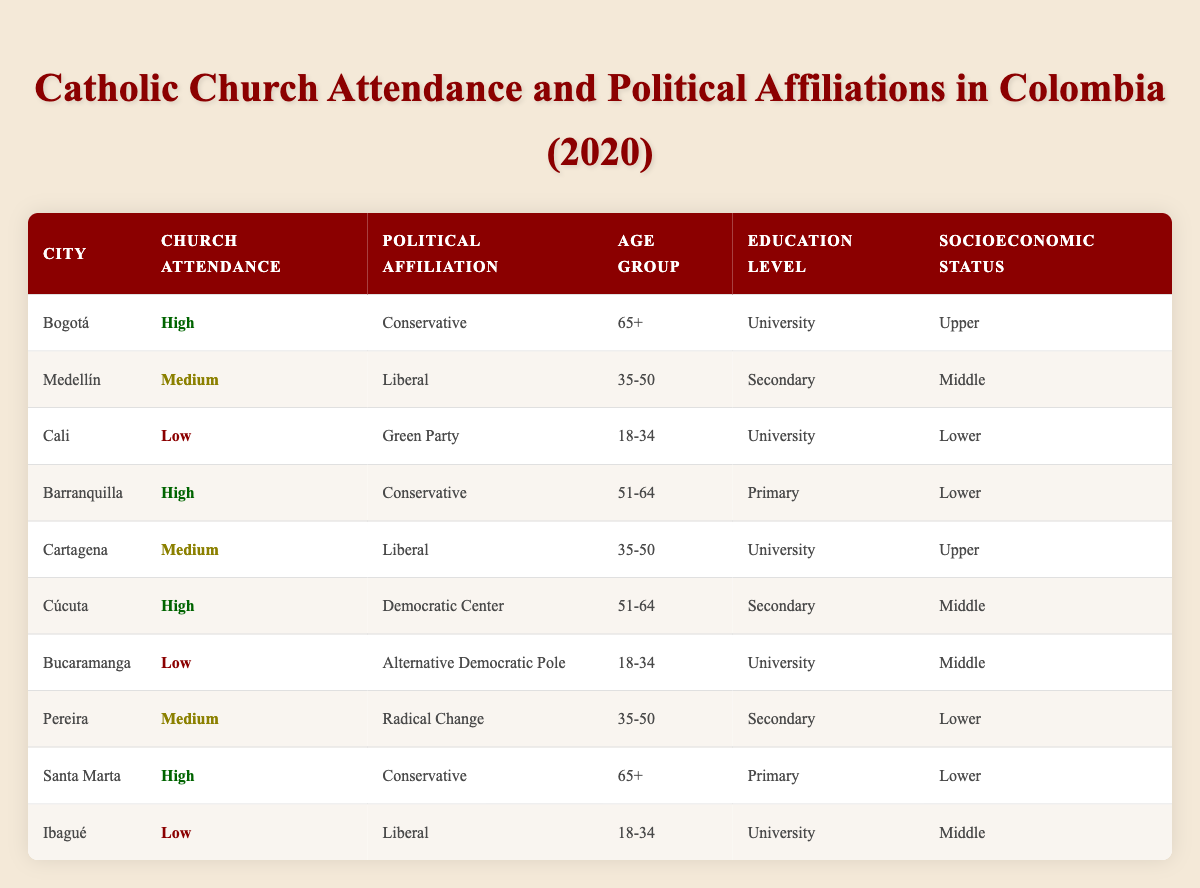What is the political affiliation of the residents of Bogotá? The table lists Bogotá with a Church Attendance labeled 'High' and a Political Affiliation of 'Conservative'. Thus, the political affiliation of the residents of Bogotá is Conservative.
Answer: Conservative How many cities have High Church Attendance and are affiliated with the Conservative party? From the table, Bogotá, Barranquilla, and Santa Marta are the three cities listed with High Church Attendance and Conservative affiliation. Therefore, there are three cities that meet these criteria.
Answer: 3 Are there any cities where individuals with Low Church Attendance are affiliated with Liberal parties? The table shows that Cali and Ibagué have Low Church Attendance and are associated with the Liberal political affiliation. Hence, the answer is yes.
Answer: Yes What is the average age group of individuals attending Church High in the provided data? The table lists three cities with High Church Attendance: Bogotá (65+), Barranquilla (51-64), and Santa Marta (65+). To find the average, add the age groups (65+ + 51-64 + 65+) and divide by 3. The calculation leads us to average age group (average of the middle age of the groups) results in roughly 63+ years.
Answer: 63+ Is there a relationship between Church Attendance and Political Affiliation among younger age groups (18-34)? In the table, Cali and Bucaramanga show Low Church Attendance with affiliations to the Green Party and Alternative Democratic Pole, while Ibagué has Low Church Attendance and is affiliated with the Liberal party. All relate to individuals aged 18-34. Therefore, political diversity exists in this age group despite the Low Church Attendance. Therefore, a relationship exists emphasizing Low Church Attendance correlates with specific political affiliations among younger groups.
Answer: Yes How many political affiliations are represented in cities with Medium Church Attendance? Analyzing the table, the cities of Medellín (Liberal), Cartagena (Liberal), and Pereira (Radical Change) show Medium Church Attendance, which reflects three different political affiliations.
Answer: 3 Which education level is most prevalent among participants with High Church Attendance? The table indicates that the individuals with High Church Attendance have diverse education levels: Bogotá (University), Barranquilla (Primary), Santa Marta (Primary). While Primary education is represented twice and University education once, Primary education is the most prevalent among the High Church Attendees.
Answer: Primary What is the socioeconomic status of the city with the Lowest Church Attendance? For cities with Low Church Attendance, Cali and Bucaramanga are both marked as Lower and Middle socioeconomic statuses respectively. Therefore, the answer indicates multiple statuses, with Lower being the most frequent.
Answer: Lower What socio-economic class corresponds to individuals affiliated with the Democratic Center Party? Analyzing the data, Cúcuta, which is affiliated with the Democratic Center party, is categorized under Middle socioeconomic status. Hence, that corresponds to the Democratic Center Party.
Answer: Middle 